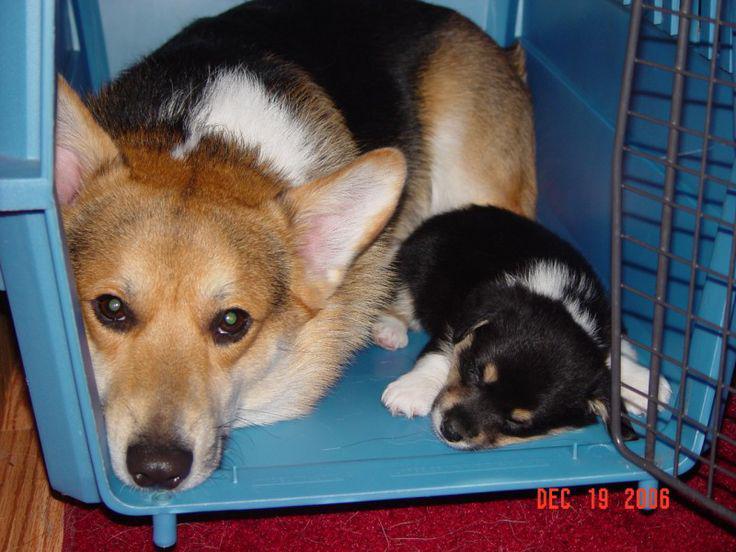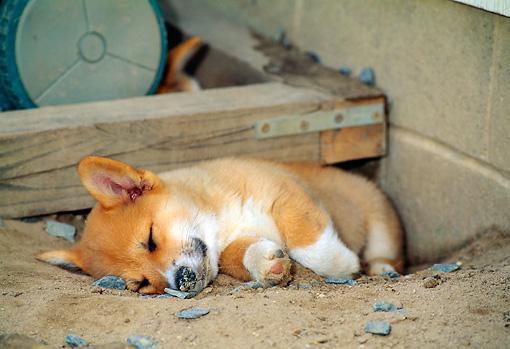The first image is the image on the left, the second image is the image on the right. Given the left and right images, does the statement "An image shows one orange-and-white dog, which is sprawling flat on its belly." hold true? Answer yes or no. No. The first image is the image on the left, the second image is the image on the right. For the images shown, is this caption "There are three dogs in total." true? Answer yes or no. Yes. 